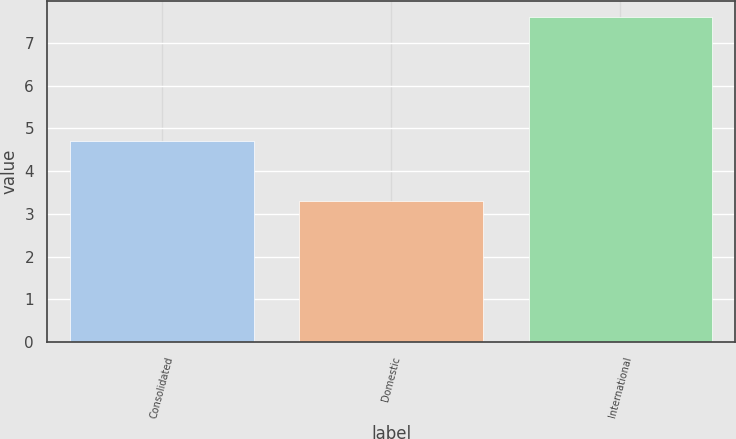Convert chart to OTSL. <chart><loc_0><loc_0><loc_500><loc_500><bar_chart><fcel>Consolidated<fcel>Domestic<fcel>International<nl><fcel>4.7<fcel>3.3<fcel>7.6<nl></chart> 